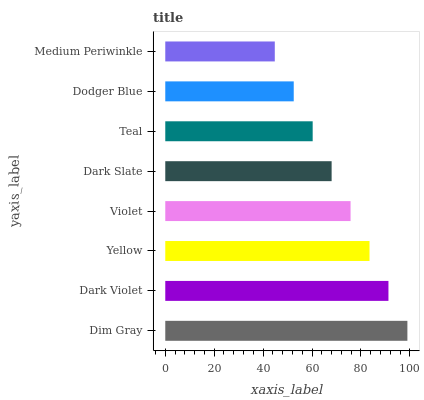Is Medium Periwinkle the minimum?
Answer yes or no. Yes. Is Dim Gray the maximum?
Answer yes or no. Yes. Is Dark Violet the minimum?
Answer yes or no. No. Is Dark Violet the maximum?
Answer yes or no. No. Is Dim Gray greater than Dark Violet?
Answer yes or no. Yes. Is Dark Violet less than Dim Gray?
Answer yes or no. Yes. Is Dark Violet greater than Dim Gray?
Answer yes or no. No. Is Dim Gray less than Dark Violet?
Answer yes or no. No. Is Violet the high median?
Answer yes or no. Yes. Is Dark Slate the low median?
Answer yes or no. Yes. Is Medium Periwinkle the high median?
Answer yes or no. No. Is Dim Gray the low median?
Answer yes or no. No. 